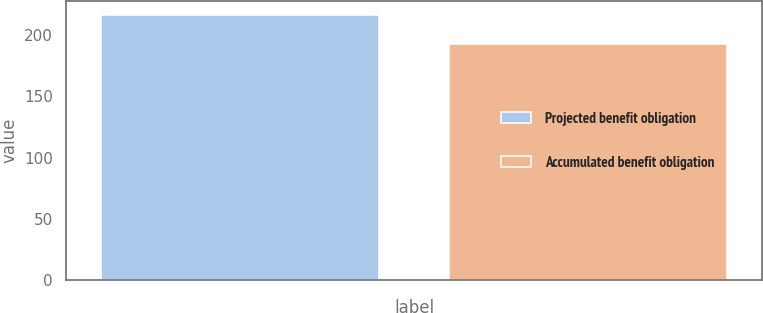Convert chart to OTSL. <chart><loc_0><loc_0><loc_500><loc_500><bar_chart><fcel>Projected benefit obligation<fcel>Accumulated benefit obligation<nl><fcel>216.5<fcel>192.4<nl></chart> 